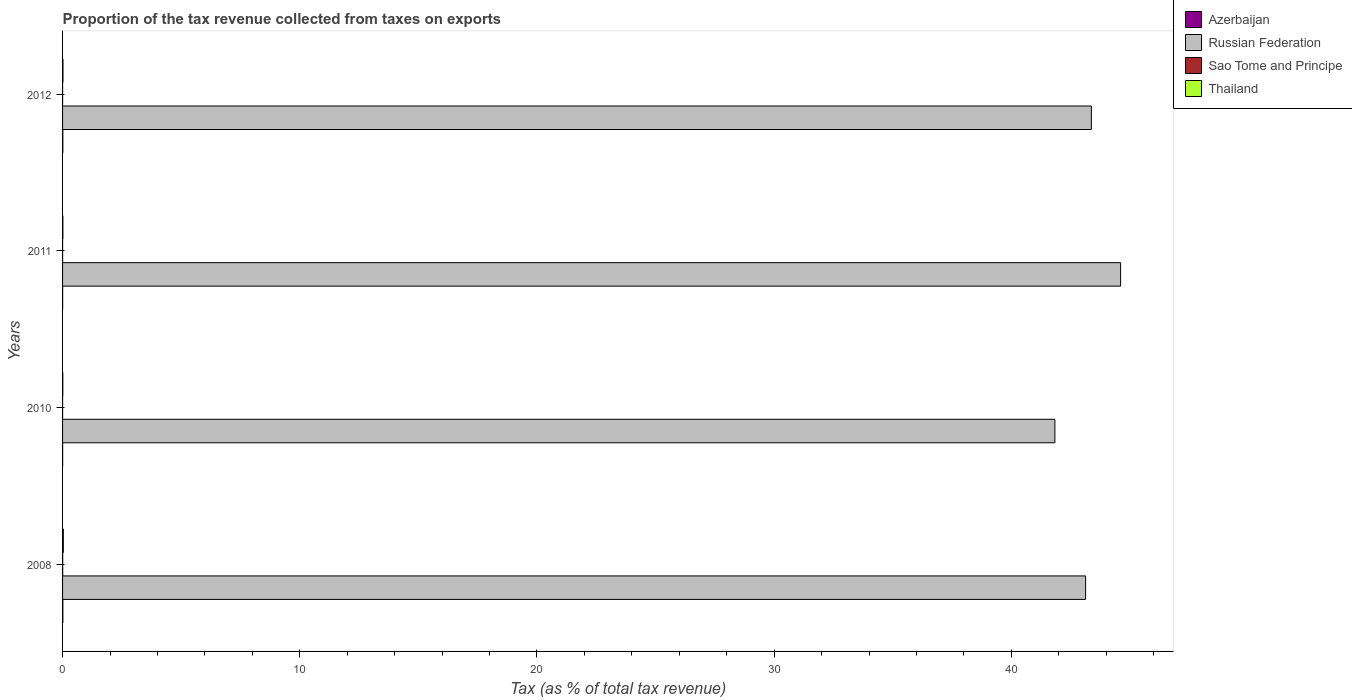How many different coloured bars are there?
Keep it short and to the point. 4. Are the number of bars per tick equal to the number of legend labels?
Your response must be concise. Yes. Are the number of bars on each tick of the Y-axis equal?
Your answer should be compact. Yes. How many bars are there on the 4th tick from the top?
Provide a short and direct response. 4. What is the proportion of the tax revenue collected in Sao Tome and Principe in 2012?
Make the answer very short. 0. Across all years, what is the maximum proportion of the tax revenue collected in Sao Tome and Principe?
Your answer should be very brief. 0.01. Across all years, what is the minimum proportion of the tax revenue collected in Sao Tome and Principe?
Give a very brief answer. 0. In which year was the proportion of the tax revenue collected in Azerbaijan maximum?
Ensure brevity in your answer.  2008. What is the total proportion of the tax revenue collected in Azerbaijan in the graph?
Provide a succinct answer. 0.03. What is the difference between the proportion of the tax revenue collected in Sao Tome and Principe in 2008 and that in 2012?
Give a very brief answer. 0. What is the difference between the proportion of the tax revenue collected in Thailand in 2010 and the proportion of the tax revenue collected in Russian Federation in 2012?
Keep it short and to the point. -43.36. What is the average proportion of the tax revenue collected in Thailand per year?
Ensure brevity in your answer.  0.02. In the year 2012, what is the difference between the proportion of the tax revenue collected in Russian Federation and proportion of the tax revenue collected in Thailand?
Provide a succinct answer. 43.36. What is the ratio of the proportion of the tax revenue collected in Azerbaijan in 2008 to that in 2012?
Provide a succinct answer. 1.06. Is the difference between the proportion of the tax revenue collected in Russian Federation in 2008 and 2010 greater than the difference between the proportion of the tax revenue collected in Thailand in 2008 and 2010?
Provide a short and direct response. Yes. What is the difference between the highest and the second highest proportion of the tax revenue collected in Russian Federation?
Provide a short and direct response. 1.23. What is the difference between the highest and the lowest proportion of the tax revenue collected in Azerbaijan?
Provide a short and direct response. 0.01. Is the sum of the proportion of the tax revenue collected in Russian Federation in 2008 and 2011 greater than the maximum proportion of the tax revenue collected in Sao Tome and Principe across all years?
Your answer should be compact. Yes. What does the 3rd bar from the top in 2012 represents?
Keep it short and to the point. Russian Federation. What does the 4th bar from the bottom in 2008 represents?
Your response must be concise. Thailand. Is it the case that in every year, the sum of the proportion of the tax revenue collected in Russian Federation and proportion of the tax revenue collected in Sao Tome and Principe is greater than the proportion of the tax revenue collected in Thailand?
Your answer should be compact. Yes. How many years are there in the graph?
Provide a short and direct response. 4. Are the values on the major ticks of X-axis written in scientific E-notation?
Provide a short and direct response. No. Does the graph contain any zero values?
Your response must be concise. No. Does the graph contain grids?
Make the answer very short. No. How many legend labels are there?
Keep it short and to the point. 4. How are the legend labels stacked?
Offer a very short reply. Vertical. What is the title of the graph?
Your response must be concise. Proportion of the tax revenue collected from taxes on exports. Does "El Salvador" appear as one of the legend labels in the graph?
Provide a succinct answer. No. What is the label or title of the X-axis?
Offer a terse response. Tax (as % of total tax revenue). What is the label or title of the Y-axis?
Offer a very short reply. Years. What is the Tax (as % of total tax revenue) in Azerbaijan in 2008?
Your response must be concise. 0.01. What is the Tax (as % of total tax revenue) in Russian Federation in 2008?
Offer a very short reply. 43.13. What is the Tax (as % of total tax revenue) in Sao Tome and Principe in 2008?
Offer a very short reply. 0.01. What is the Tax (as % of total tax revenue) in Thailand in 2008?
Your response must be concise. 0.03. What is the Tax (as % of total tax revenue) in Azerbaijan in 2010?
Offer a terse response. 0. What is the Tax (as % of total tax revenue) of Russian Federation in 2010?
Provide a short and direct response. 41.84. What is the Tax (as % of total tax revenue) of Sao Tome and Principe in 2010?
Your answer should be very brief. 0. What is the Tax (as % of total tax revenue) in Thailand in 2010?
Your answer should be very brief. 0.01. What is the Tax (as % of total tax revenue) of Azerbaijan in 2011?
Your answer should be compact. 0. What is the Tax (as % of total tax revenue) of Russian Federation in 2011?
Offer a very short reply. 44.61. What is the Tax (as % of total tax revenue) in Sao Tome and Principe in 2011?
Provide a short and direct response. 0. What is the Tax (as % of total tax revenue) in Thailand in 2011?
Your answer should be compact. 0.01. What is the Tax (as % of total tax revenue) of Azerbaijan in 2012?
Make the answer very short. 0.01. What is the Tax (as % of total tax revenue) of Russian Federation in 2012?
Offer a terse response. 43.37. What is the Tax (as % of total tax revenue) of Sao Tome and Principe in 2012?
Give a very brief answer. 0. What is the Tax (as % of total tax revenue) of Thailand in 2012?
Your answer should be compact. 0.02. Across all years, what is the maximum Tax (as % of total tax revenue) of Azerbaijan?
Keep it short and to the point. 0.01. Across all years, what is the maximum Tax (as % of total tax revenue) in Russian Federation?
Your response must be concise. 44.61. Across all years, what is the maximum Tax (as % of total tax revenue) of Sao Tome and Principe?
Your answer should be very brief. 0.01. Across all years, what is the maximum Tax (as % of total tax revenue) in Thailand?
Your answer should be very brief. 0.03. Across all years, what is the minimum Tax (as % of total tax revenue) of Azerbaijan?
Make the answer very short. 0. Across all years, what is the minimum Tax (as % of total tax revenue) of Russian Federation?
Ensure brevity in your answer.  41.84. Across all years, what is the minimum Tax (as % of total tax revenue) in Sao Tome and Principe?
Provide a succinct answer. 0. Across all years, what is the minimum Tax (as % of total tax revenue) of Thailand?
Your answer should be compact. 0.01. What is the total Tax (as % of total tax revenue) of Azerbaijan in the graph?
Offer a very short reply. 0.03. What is the total Tax (as % of total tax revenue) in Russian Federation in the graph?
Offer a terse response. 172.95. What is the total Tax (as % of total tax revenue) of Sao Tome and Principe in the graph?
Your answer should be compact. 0.01. What is the total Tax (as % of total tax revenue) in Thailand in the graph?
Ensure brevity in your answer.  0.07. What is the difference between the Tax (as % of total tax revenue) of Azerbaijan in 2008 and that in 2010?
Provide a succinct answer. 0.01. What is the difference between the Tax (as % of total tax revenue) in Russian Federation in 2008 and that in 2010?
Keep it short and to the point. 1.3. What is the difference between the Tax (as % of total tax revenue) in Sao Tome and Principe in 2008 and that in 2010?
Keep it short and to the point. 0. What is the difference between the Tax (as % of total tax revenue) in Thailand in 2008 and that in 2010?
Keep it short and to the point. 0.02. What is the difference between the Tax (as % of total tax revenue) in Azerbaijan in 2008 and that in 2011?
Make the answer very short. 0.01. What is the difference between the Tax (as % of total tax revenue) of Russian Federation in 2008 and that in 2011?
Provide a succinct answer. -1.48. What is the difference between the Tax (as % of total tax revenue) in Sao Tome and Principe in 2008 and that in 2011?
Make the answer very short. 0. What is the difference between the Tax (as % of total tax revenue) of Thailand in 2008 and that in 2011?
Your answer should be compact. 0.02. What is the difference between the Tax (as % of total tax revenue) of Azerbaijan in 2008 and that in 2012?
Offer a terse response. 0. What is the difference between the Tax (as % of total tax revenue) in Russian Federation in 2008 and that in 2012?
Provide a succinct answer. -0.24. What is the difference between the Tax (as % of total tax revenue) of Sao Tome and Principe in 2008 and that in 2012?
Give a very brief answer. 0. What is the difference between the Tax (as % of total tax revenue) in Thailand in 2008 and that in 2012?
Offer a terse response. 0.02. What is the difference between the Tax (as % of total tax revenue) of Azerbaijan in 2010 and that in 2011?
Offer a terse response. 0. What is the difference between the Tax (as % of total tax revenue) in Russian Federation in 2010 and that in 2011?
Offer a very short reply. -2.77. What is the difference between the Tax (as % of total tax revenue) of Sao Tome and Principe in 2010 and that in 2011?
Your answer should be compact. -0. What is the difference between the Tax (as % of total tax revenue) of Thailand in 2010 and that in 2011?
Provide a succinct answer. -0. What is the difference between the Tax (as % of total tax revenue) of Azerbaijan in 2010 and that in 2012?
Your answer should be compact. -0.01. What is the difference between the Tax (as % of total tax revenue) in Russian Federation in 2010 and that in 2012?
Offer a very short reply. -1.54. What is the difference between the Tax (as % of total tax revenue) in Sao Tome and Principe in 2010 and that in 2012?
Give a very brief answer. -0. What is the difference between the Tax (as % of total tax revenue) of Thailand in 2010 and that in 2012?
Your response must be concise. -0.01. What is the difference between the Tax (as % of total tax revenue) in Azerbaijan in 2011 and that in 2012?
Offer a very short reply. -0.01. What is the difference between the Tax (as % of total tax revenue) of Russian Federation in 2011 and that in 2012?
Make the answer very short. 1.23. What is the difference between the Tax (as % of total tax revenue) in Sao Tome and Principe in 2011 and that in 2012?
Make the answer very short. -0. What is the difference between the Tax (as % of total tax revenue) of Thailand in 2011 and that in 2012?
Your answer should be very brief. -0. What is the difference between the Tax (as % of total tax revenue) in Azerbaijan in 2008 and the Tax (as % of total tax revenue) in Russian Federation in 2010?
Your response must be concise. -41.82. What is the difference between the Tax (as % of total tax revenue) in Azerbaijan in 2008 and the Tax (as % of total tax revenue) in Sao Tome and Principe in 2010?
Give a very brief answer. 0.01. What is the difference between the Tax (as % of total tax revenue) in Azerbaijan in 2008 and the Tax (as % of total tax revenue) in Thailand in 2010?
Offer a terse response. 0. What is the difference between the Tax (as % of total tax revenue) in Russian Federation in 2008 and the Tax (as % of total tax revenue) in Sao Tome and Principe in 2010?
Provide a short and direct response. 43.13. What is the difference between the Tax (as % of total tax revenue) of Russian Federation in 2008 and the Tax (as % of total tax revenue) of Thailand in 2010?
Offer a very short reply. 43.12. What is the difference between the Tax (as % of total tax revenue) of Sao Tome and Principe in 2008 and the Tax (as % of total tax revenue) of Thailand in 2010?
Your answer should be compact. -0.01. What is the difference between the Tax (as % of total tax revenue) of Azerbaijan in 2008 and the Tax (as % of total tax revenue) of Russian Federation in 2011?
Your response must be concise. -44.6. What is the difference between the Tax (as % of total tax revenue) of Azerbaijan in 2008 and the Tax (as % of total tax revenue) of Sao Tome and Principe in 2011?
Provide a succinct answer. 0.01. What is the difference between the Tax (as % of total tax revenue) in Azerbaijan in 2008 and the Tax (as % of total tax revenue) in Thailand in 2011?
Give a very brief answer. -0. What is the difference between the Tax (as % of total tax revenue) in Russian Federation in 2008 and the Tax (as % of total tax revenue) in Sao Tome and Principe in 2011?
Your answer should be compact. 43.13. What is the difference between the Tax (as % of total tax revenue) of Russian Federation in 2008 and the Tax (as % of total tax revenue) of Thailand in 2011?
Your answer should be very brief. 43.12. What is the difference between the Tax (as % of total tax revenue) of Sao Tome and Principe in 2008 and the Tax (as % of total tax revenue) of Thailand in 2011?
Provide a short and direct response. -0.01. What is the difference between the Tax (as % of total tax revenue) of Azerbaijan in 2008 and the Tax (as % of total tax revenue) of Russian Federation in 2012?
Your response must be concise. -43.36. What is the difference between the Tax (as % of total tax revenue) in Azerbaijan in 2008 and the Tax (as % of total tax revenue) in Sao Tome and Principe in 2012?
Keep it short and to the point. 0.01. What is the difference between the Tax (as % of total tax revenue) in Azerbaijan in 2008 and the Tax (as % of total tax revenue) in Thailand in 2012?
Offer a terse response. -0. What is the difference between the Tax (as % of total tax revenue) of Russian Federation in 2008 and the Tax (as % of total tax revenue) of Sao Tome and Principe in 2012?
Your answer should be very brief. 43.13. What is the difference between the Tax (as % of total tax revenue) in Russian Federation in 2008 and the Tax (as % of total tax revenue) in Thailand in 2012?
Make the answer very short. 43.12. What is the difference between the Tax (as % of total tax revenue) of Sao Tome and Principe in 2008 and the Tax (as % of total tax revenue) of Thailand in 2012?
Keep it short and to the point. -0.01. What is the difference between the Tax (as % of total tax revenue) of Azerbaijan in 2010 and the Tax (as % of total tax revenue) of Russian Federation in 2011?
Keep it short and to the point. -44.6. What is the difference between the Tax (as % of total tax revenue) in Azerbaijan in 2010 and the Tax (as % of total tax revenue) in Sao Tome and Principe in 2011?
Your answer should be very brief. 0. What is the difference between the Tax (as % of total tax revenue) in Azerbaijan in 2010 and the Tax (as % of total tax revenue) in Thailand in 2011?
Keep it short and to the point. -0.01. What is the difference between the Tax (as % of total tax revenue) in Russian Federation in 2010 and the Tax (as % of total tax revenue) in Sao Tome and Principe in 2011?
Offer a terse response. 41.84. What is the difference between the Tax (as % of total tax revenue) in Russian Federation in 2010 and the Tax (as % of total tax revenue) in Thailand in 2011?
Your response must be concise. 41.82. What is the difference between the Tax (as % of total tax revenue) of Sao Tome and Principe in 2010 and the Tax (as % of total tax revenue) of Thailand in 2011?
Provide a short and direct response. -0.01. What is the difference between the Tax (as % of total tax revenue) of Azerbaijan in 2010 and the Tax (as % of total tax revenue) of Russian Federation in 2012?
Keep it short and to the point. -43.37. What is the difference between the Tax (as % of total tax revenue) of Azerbaijan in 2010 and the Tax (as % of total tax revenue) of Sao Tome and Principe in 2012?
Keep it short and to the point. 0. What is the difference between the Tax (as % of total tax revenue) in Azerbaijan in 2010 and the Tax (as % of total tax revenue) in Thailand in 2012?
Your response must be concise. -0.01. What is the difference between the Tax (as % of total tax revenue) in Russian Federation in 2010 and the Tax (as % of total tax revenue) in Sao Tome and Principe in 2012?
Your response must be concise. 41.84. What is the difference between the Tax (as % of total tax revenue) of Russian Federation in 2010 and the Tax (as % of total tax revenue) of Thailand in 2012?
Provide a succinct answer. 41.82. What is the difference between the Tax (as % of total tax revenue) of Sao Tome and Principe in 2010 and the Tax (as % of total tax revenue) of Thailand in 2012?
Give a very brief answer. -0.02. What is the difference between the Tax (as % of total tax revenue) of Azerbaijan in 2011 and the Tax (as % of total tax revenue) of Russian Federation in 2012?
Give a very brief answer. -43.37. What is the difference between the Tax (as % of total tax revenue) in Azerbaijan in 2011 and the Tax (as % of total tax revenue) in Sao Tome and Principe in 2012?
Give a very brief answer. 0. What is the difference between the Tax (as % of total tax revenue) of Azerbaijan in 2011 and the Tax (as % of total tax revenue) of Thailand in 2012?
Keep it short and to the point. -0.01. What is the difference between the Tax (as % of total tax revenue) in Russian Federation in 2011 and the Tax (as % of total tax revenue) in Sao Tome and Principe in 2012?
Keep it short and to the point. 44.61. What is the difference between the Tax (as % of total tax revenue) of Russian Federation in 2011 and the Tax (as % of total tax revenue) of Thailand in 2012?
Your answer should be compact. 44.59. What is the difference between the Tax (as % of total tax revenue) in Sao Tome and Principe in 2011 and the Tax (as % of total tax revenue) in Thailand in 2012?
Give a very brief answer. -0.02. What is the average Tax (as % of total tax revenue) of Azerbaijan per year?
Ensure brevity in your answer.  0.01. What is the average Tax (as % of total tax revenue) of Russian Federation per year?
Make the answer very short. 43.24. What is the average Tax (as % of total tax revenue) of Sao Tome and Principe per year?
Offer a terse response. 0. What is the average Tax (as % of total tax revenue) in Thailand per year?
Ensure brevity in your answer.  0.02. In the year 2008, what is the difference between the Tax (as % of total tax revenue) of Azerbaijan and Tax (as % of total tax revenue) of Russian Federation?
Provide a succinct answer. -43.12. In the year 2008, what is the difference between the Tax (as % of total tax revenue) of Azerbaijan and Tax (as % of total tax revenue) of Sao Tome and Principe?
Offer a terse response. 0.01. In the year 2008, what is the difference between the Tax (as % of total tax revenue) of Azerbaijan and Tax (as % of total tax revenue) of Thailand?
Offer a very short reply. -0.02. In the year 2008, what is the difference between the Tax (as % of total tax revenue) in Russian Federation and Tax (as % of total tax revenue) in Sao Tome and Principe?
Offer a very short reply. 43.13. In the year 2008, what is the difference between the Tax (as % of total tax revenue) of Russian Federation and Tax (as % of total tax revenue) of Thailand?
Ensure brevity in your answer.  43.1. In the year 2008, what is the difference between the Tax (as % of total tax revenue) in Sao Tome and Principe and Tax (as % of total tax revenue) in Thailand?
Offer a very short reply. -0.03. In the year 2010, what is the difference between the Tax (as % of total tax revenue) of Azerbaijan and Tax (as % of total tax revenue) of Russian Federation?
Offer a terse response. -41.83. In the year 2010, what is the difference between the Tax (as % of total tax revenue) in Azerbaijan and Tax (as % of total tax revenue) in Sao Tome and Principe?
Your answer should be very brief. 0. In the year 2010, what is the difference between the Tax (as % of total tax revenue) in Azerbaijan and Tax (as % of total tax revenue) in Thailand?
Offer a terse response. -0.01. In the year 2010, what is the difference between the Tax (as % of total tax revenue) in Russian Federation and Tax (as % of total tax revenue) in Sao Tome and Principe?
Ensure brevity in your answer.  41.84. In the year 2010, what is the difference between the Tax (as % of total tax revenue) in Russian Federation and Tax (as % of total tax revenue) in Thailand?
Offer a terse response. 41.83. In the year 2010, what is the difference between the Tax (as % of total tax revenue) of Sao Tome and Principe and Tax (as % of total tax revenue) of Thailand?
Keep it short and to the point. -0.01. In the year 2011, what is the difference between the Tax (as % of total tax revenue) of Azerbaijan and Tax (as % of total tax revenue) of Russian Federation?
Provide a succinct answer. -44.6. In the year 2011, what is the difference between the Tax (as % of total tax revenue) of Azerbaijan and Tax (as % of total tax revenue) of Sao Tome and Principe?
Your answer should be very brief. 0. In the year 2011, what is the difference between the Tax (as % of total tax revenue) of Azerbaijan and Tax (as % of total tax revenue) of Thailand?
Your answer should be compact. -0.01. In the year 2011, what is the difference between the Tax (as % of total tax revenue) of Russian Federation and Tax (as % of total tax revenue) of Sao Tome and Principe?
Make the answer very short. 44.61. In the year 2011, what is the difference between the Tax (as % of total tax revenue) of Russian Federation and Tax (as % of total tax revenue) of Thailand?
Give a very brief answer. 44.59. In the year 2011, what is the difference between the Tax (as % of total tax revenue) in Sao Tome and Principe and Tax (as % of total tax revenue) in Thailand?
Ensure brevity in your answer.  -0.01. In the year 2012, what is the difference between the Tax (as % of total tax revenue) of Azerbaijan and Tax (as % of total tax revenue) of Russian Federation?
Provide a short and direct response. -43.36. In the year 2012, what is the difference between the Tax (as % of total tax revenue) in Azerbaijan and Tax (as % of total tax revenue) in Sao Tome and Principe?
Provide a short and direct response. 0.01. In the year 2012, what is the difference between the Tax (as % of total tax revenue) in Azerbaijan and Tax (as % of total tax revenue) in Thailand?
Your response must be concise. -0.01. In the year 2012, what is the difference between the Tax (as % of total tax revenue) of Russian Federation and Tax (as % of total tax revenue) of Sao Tome and Principe?
Offer a terse response. 43.37. In the year 2012, what is the difference between the Tax (as % of total tax revenue) of Russian Federation and Tax (as % of total tax revenue) of Thailand?
Provide a succinct answer. 43.36. In the year 2012, what is the difference between the Tax (as % of total tax revenue) in Sao Tome and Principe and Tax (as % of total tax revenue) in Thailand?
Offer a terse response. -0.02. What is the ratio of the Tax (as % of total tax revenue) of Azerbaijan in 2008 to that in 2010?
Offer a very short reply. 3.13. What is the ratio of the Tax (as % of total tax revenue) of Russian Federation in 2008 to that in 2010?
Your response must be concise. 1.03. What is the ratio of the Tax (as % of total tax revenue) of Sao Tome and Principe in 2008 to that in 2010?
Make the answer very short. 5.8. What is the ratio of the Tax (as % of total tax revenue) in Thailand in 2008 to that in 2010?
Give a very brief answer. 3.23. What is the ratio of the Tax (as % of total tax revenue) in Azerbaijan in 2008 to that in 2011?
Your answer should be very brief. 3.86. What is the ratio of the Tax (as % of total tax revenue) in Russian Federation in 2008 to that in 2011?
Ensure brevity in your answer.  0.97. What is the ratio of the Tax (as % of total tax revenue) in Sao Tome and Principe in 2008 to that in 2011?
Give a very brief answer. 4.43. What is the ratio of the Tax (as % of total tax revenue) of Thailand in 2008 to that in 2011?
Give a very brief answer. 2.59. What is the ratio of the Tax (as % of total tax revenue) of Azerbaijan in 2008 to that in 2012?
Provide a short and direct response. 1.06. What is the ratio of the Tax (as % of total tax revenue) of Sao Tome and Principe in 2008 to that in 2012?
Provide a succinct answer. 3.59. What is the ratio of the Tax (as % of total tax revenue) of Thailand in 2008 to that in 2012?
Offer a very short reply. 1.96. What is the ratio of the Tax (as % of total tax revenue) of Azerbaijan in 2010 to that in 2011?
Keep it short and to the point. 1.23. What is the ratio of the Tax (as % of total tax revenue) of Russian Federation in 2010 to that in 2011?
Make the answer very short. 0.94. What is the ratio of the Tax (as % of total tax revenue) in Sao Tome and Principe in 2010 to that in 2011?
Provide a succinct answer. 0.76. What is the ratio of the Tax (as % of total tax revenue) of Thailand in 2010 to that in 2011?
Your response must be concise. 0.8. What is the ratio of the Tax (as % of total tax revenue) in Azerbaijan in 2010 to that in 2012?
Keep it short and to the point. 0.34. What is the ratio of the Tax (as % of total tax revenue) of Russian Federation in 2010 to that in 2012?
Provide a short and direct response. 0.96. What is the ratio of the Tax (as % of total tax revenue) of Sao Tome and Principe in 2010 to that in 2012?
Your answer should be compact. 0.62. What is the ratio of the Tax (as % of total tax revenue) of Thailand in 2010 to that in 2012?
Offer a terse response. 0.61. What is the ratio of the Tax (as % of total tax revenue) in Azerbaijan in 2011 to that in 2012?
Offer a terse response. 0.27. What is the ratio of the Tax (as % of total tax revenue) in Russian Federation in 2011 to that in 2012?
Ensure brevity in your answer.  1.03. What is the ratio of the Tax (as % of total tax revenue) of Sao Tome and Principe in 2011 to that in 2012?
Your answer should be compact. 0.81. What is the ratio of the Tax (as % of total tax revenue) in Thailand in 2011 to that in 2012?
Provide a short and direct response. 0.76. What is the difference between the highest and the second highest Tax (as % of total tax revenue) in Azerbaijan?
Give a very brief answer. 0. What is the difference between the highest and the second highest Tax (as % of total tax revenue) in Russian Federation?
Ensure brevity in your answer.  1.23. What is the difference between the highest and the second highest Tax (as % of total tax revenue) of Sao Tome and Principe?
Give a very brief answer. 0. What is the difference between the highest and the second highest Tax (as % of total tax revenue) of Thailand?
Give a very brief answer. 0.02. What is the difference between the highest and the lowest Tax (as % of total tax revenue) in Azerbaijan?
Your response must be concise. 0.01. What is the difference between the highest and the lowest Tax (as % of total tax revenue) of Russian Federation?
Make the answer very short. 2.77. What is the difference between the highest and the lowest Tax (as % of total tax revenue) of Sao Tome and Principe?
Offer a very short reply. 0. What is the difference between the highest and the lowest Tax (as % of total tax revenue) in Thailand?
Your answer should be compact. 0.02. 